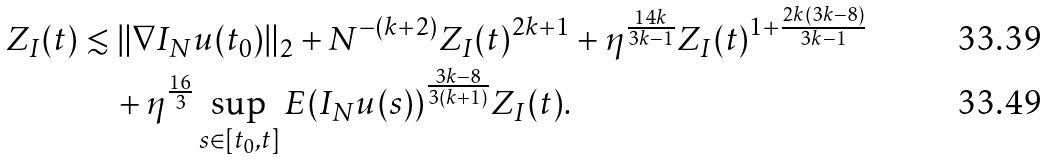Convert formula to latex. <formula><loc_0><loc_0><loc_500><loc_500>Z _ { I } ( t ) & \lesssim \| \nabla I _ { N } u ( t _ { 0 } ) \| _ { 2 } + N ^ { - ( k + 2 ) } Z _ { I } ( t ) ^ { 2 k + 1 } + \eta ^ { \frac { 1 4 k } { 3 k - 1 } } Z _ { I } ( t ) ^ { 1 + \frac { 2 k ( 3 k - 8 ) } { 3 k - 1 } } \\ & \quad + \eta ^ { \frac { 1 6 } 3 } \sup _ { s \in [ t _ { 0 } , t ] } E ( I _ { N } u ( s ) ) ^ { \frac { 3 k - 8 } { 3 ( k + 1 ) } } Z _ { I } ( t ) .</formula> 